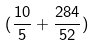Convert formula to latex. <formula><loc_0><loc_0><loc_500><loc_500>( \frac { 1 0 } { 5 } + \frac { 2 8 4 } { 5 2 } )</formula> 